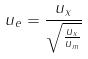Convert formula to latex. <formula><loc_0><loc_0><loc_500><loc_500>u _ { e } = \frac { u _ { x } } { \sqrt { \frac { u _ { x } } { u _ { m } } } }</formula> 